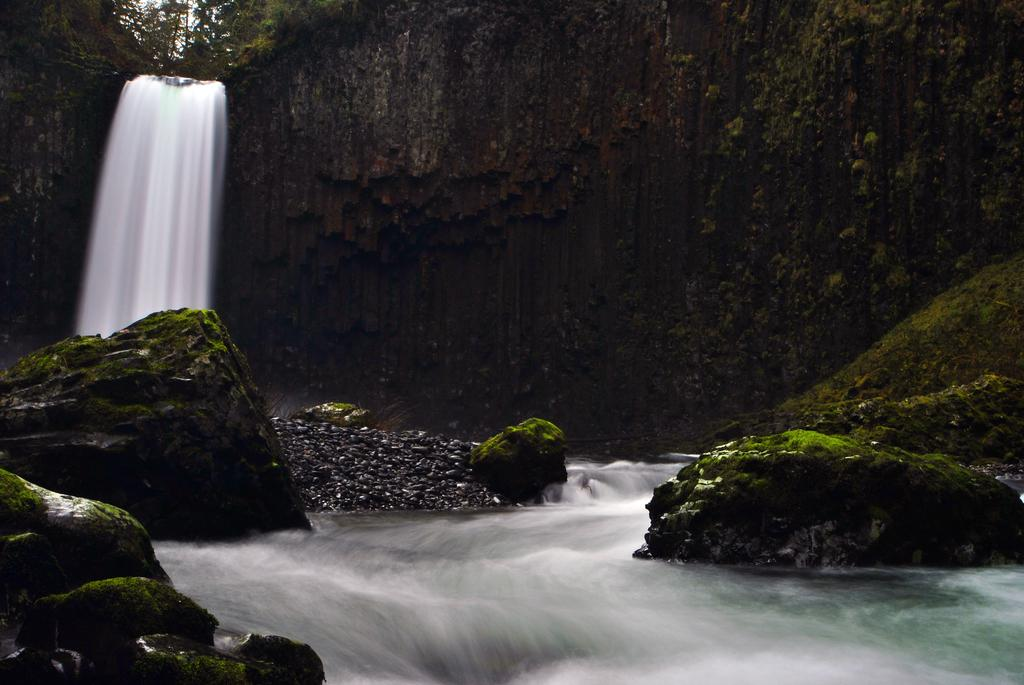What is happening in the image? There is water flowing in the image. What can be seen in the water? Rocks are visible in the image. What type of vegetation is present in the image? There are trees in the image. How many roses are on the calendar in the image? There is no calendar or rose present in the image. Can you describe the person jumping in the image? There is no person or jumping activity depicted in the image. 